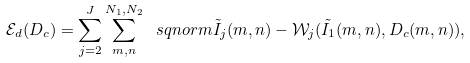<formula> <loc_0><loc_0><loc_500><loc_500>\mathcal { E } _ { d } ( D _ { c } ) = \sum _ { j = 2 } ^ { J } \sum _ { m , n } ^ { N _ { 1 } , N _ { 2 } } \ s q n o r m { \tilde { I } _ { j } ( m , n ) - \mathcal { W } _ { j } ( \tilde { I } _ { 1 } ( m , n ) , D _ { c } ( m , n ) ) } ,</formula> 